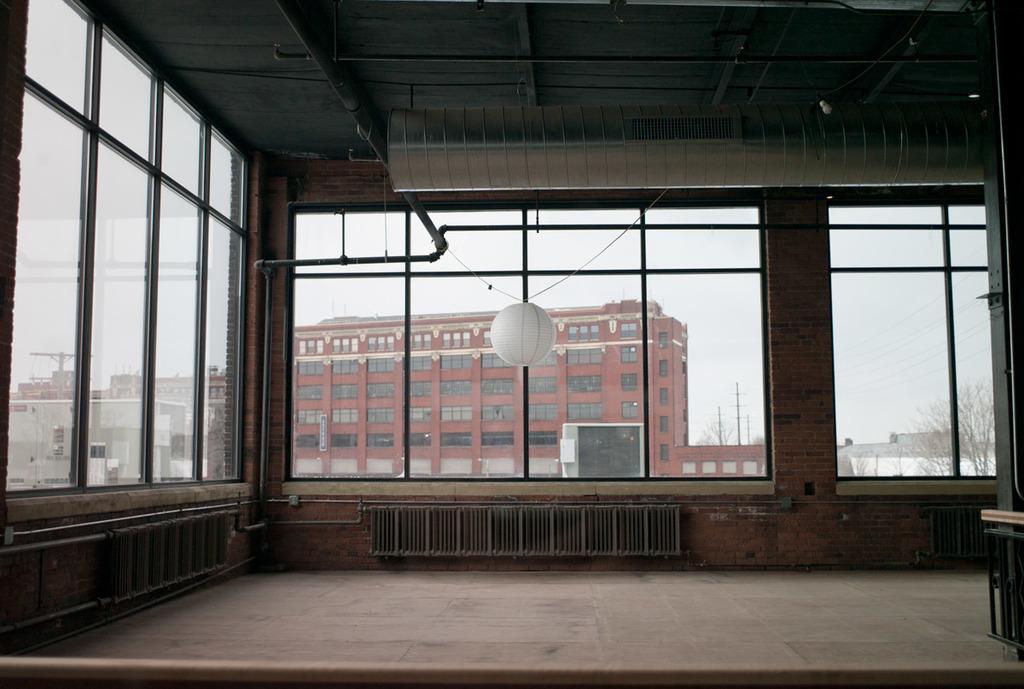Can you describe this image briefly? In this picture we can observe a room. There is a white color sphere hanging in this room. We can observe glass windows. In the background there is a maroon color building and some other buildings. On the right side there is a dried tree. We can observe a sky here. 